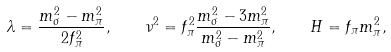<formula> <loc_0><loc_0><loc_500><loc_500>\lambda = \frac { m _ { \sigma } ^ { 2 } - m _ { \pi } ^ { 2 } } { 2 f _ { \pi } ^ { 2 } } , \quad \nu ^ { 2 } = f _ { \pi } ^ { 2 } \frac { m _ { \sigma } ^ { 2 } - 3 m _ { \pi } ^ { 2 } } { m _ { \sigma } ^ { 2 } - m _ { \pi } ^ { 2 } } , \quad H = f _ { \pi } m _ { \pi } ^ { 2 } ,</formula> 